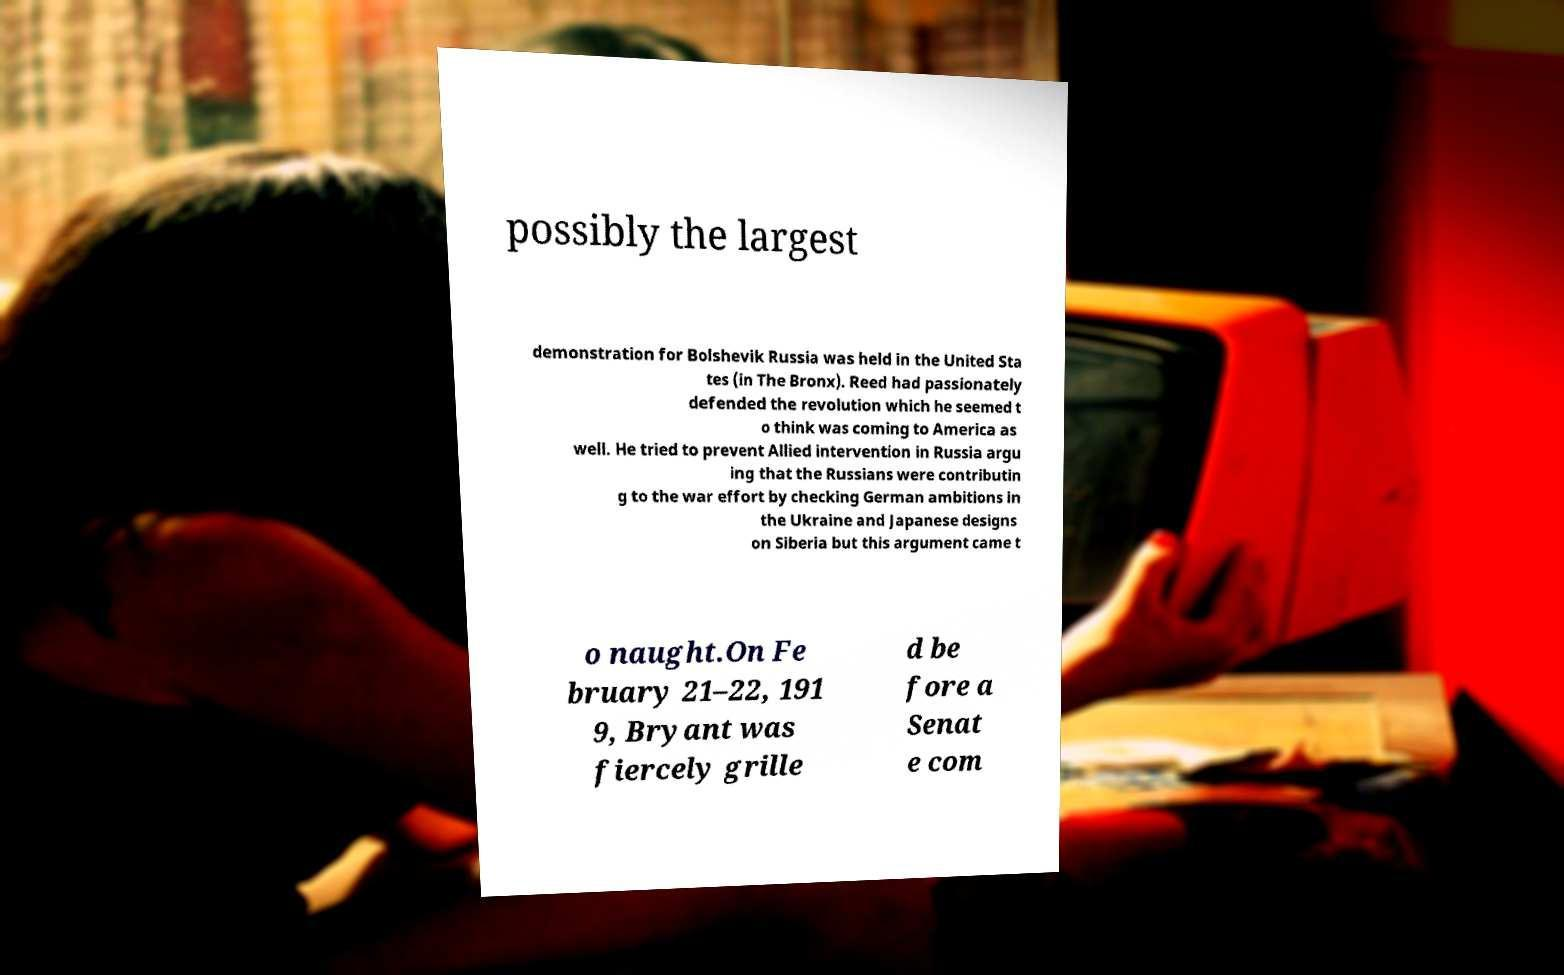What messages or text are displayed in this image? I need them in a readable, typed format. possibly the largest demonstration for Bolshevik Russia was held in the United Sta tes (in The Bronx). Reed had passionately defended the revolution which he seemed t o think was coming to America as well. He tried to prevent Allied intervention in Russia argu ing that the Russians were contributin g to the war effort by checking German ambitions in the Ukraine and Japanese designs on Siberia but this argument came t o naught.On Fe bruary 21–22, 191 9, Bryant was fiercely grille d be fore a Senat e com 